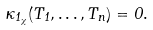Convert formula to latex. <formula><loc_0><loc_0><loc_500><loc_500>\kappa _ { 1 _ { \chi } } ( T _ { 1 } , \dots , T _ { n } ) = 0 .</formula> 